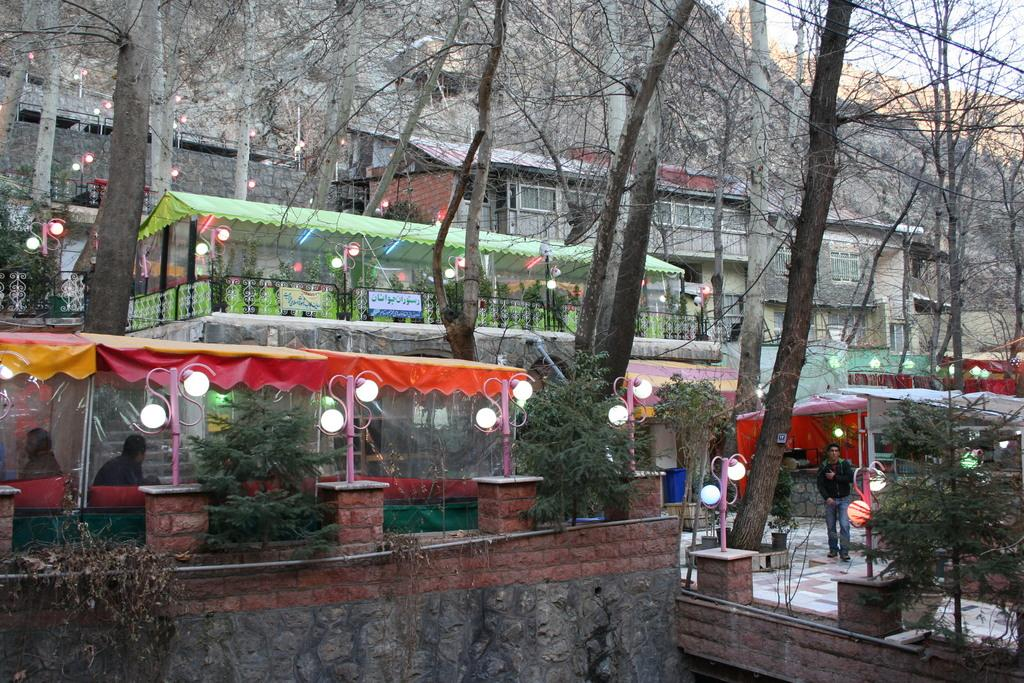What type of lighting can be seen in the image? There are street lights in the image. What type of vegetation is present in the image? There are plants and trees in the image. What can be seen in the background of the image? There are buildings and trees in the background of the image. What is the path in the image used for? The path in the image is used by people, as there are people visible on the path. Where are the people located in the image? There are people visible on a path and on the right side of the image. What type of skirt is being worn by the tree in the image? There are no trees wearing skirts in the image; trees are plants and do not wear clothing. How many floors can be seen in the image? The image does not show any buildings with multiple floors, so it is not possible to determine the number of floors. 